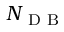<formula> <loc_0><loc_0><loc_500><loc_500>N _ { D B }</formula> 